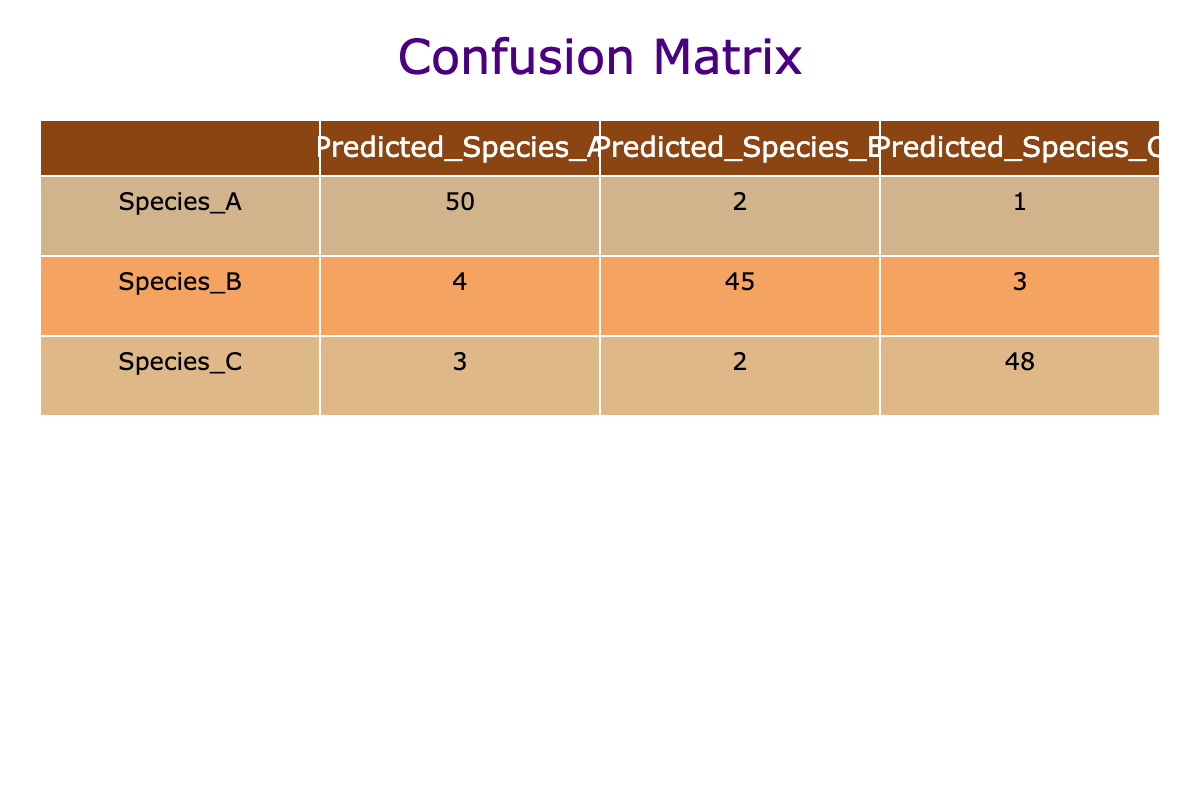What is the number of times Species A was correctly predicted? In the table, the cell for Species A under Predicted Species A shows the number 50, which represents the correct predictions for Species A.
Answer: 50 What is the total number of predicted instances for Species B? To find the total predicted instances for Species B, we add the values in the row for Species B: 4 (Predicted Species A) + 45 (Predicted Species B) + 3 (Predicted Species C), which equals 52.
Answer: 52 How many times was Species C predicted as Species A? Referring to the table, under the row for Species C and the column for Predicted Species A, the value is 3, indicating Species C was incorrectly predicted as Species A three times.
Answer: 3 What is the total number of correct predictions across all species? To calculate the total correct predictions, we take the diagonal values from the table: 50 (Species A) + 45 (Species B) + 48 (Species C). Summing them yields 143.
Answer: 143 Is it true that Species B had more correct predictions than Species C? From the table, Species B had 45 correct predictions while Species C had 48 correct predictions. Since 45 is less than 48, the statement is false.
Answer: No What is the average number of misclassifications for all species combined? Misclassifications for each species can be calculated by subtracting the correct predictions from the total predictions for each species. For Species A: 2 + 1 = 3. For Species B: 4 + 3 = 7. For Species C: 3 + 2 = 5. Total misclassifications = 3 + 7 + 5 = 15. Total predictions = 50 + 2 + 1 + 4 + 45 + 3 + 3 + 2 + 48 = 158. Average misclassifications = 15 / 3 (for the three species) = 5.
Answer: 5 How many instances of Species C were predicted correctly compared to the total instances predicted for Species C? The correct predictions for Species C is 48, while the total predictions for Species C (including both correct and incorrect) is 48 + 3 + 2 = 53. The ratio is 48 correct out of 53 total.
Answer: 48 out of 53 What is the total number of instances where Species A was incorrectly predicted? The incorrect predictions for Species A can be calculated by summing 2 (predicted as Species B) and 1 (predicted as Species C), which equals 3.
Answer: 3 Did more plants get classified as Species A than as Species C? Adding the values for the classifications, Species A predictions totaled 50 + 2 + 1 = 53, while Species C totaled 3 + 2 + 48 = 53. Since both totals are equal, the answer is no.
Answer: No 